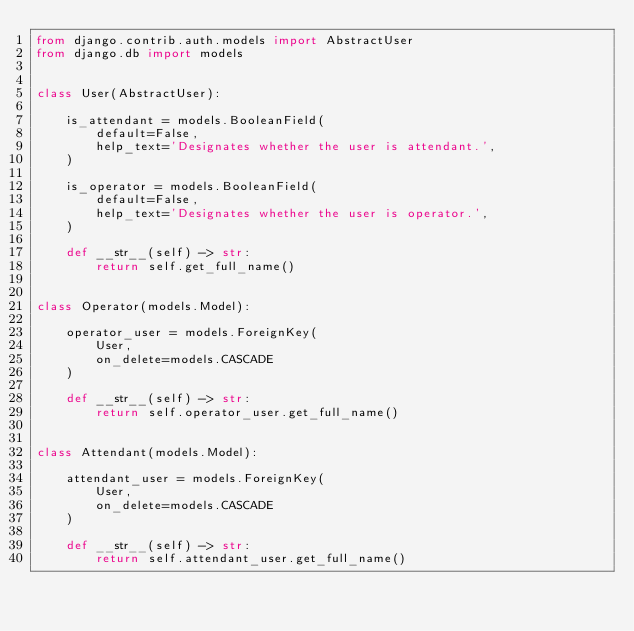<code> <loc_0><loc_0><loc_500><loc_500><_Python_>from django.contrib.auth.models import AbstractUser
from django.db import models


class User(AbstractUser):

    is_attendant = models.BooleanField(
        default=False,
        help_text='Designates whether the user is attendant.',
    )

    is_operator = models.BooleanField(
        default=False,
        help_text='Designates whether the user is operator.',
    )

    def __str__(self) -> str:
        return self.get_full_name()


class Operator(models.Model):

    operator_user = models.ForeignKey(
        User, 
        on_delete=models.CASCADE
    )

    def __str__(self) -> str:
        return self.operator_user.get_full_name()


class Attendant(models.Model):

    attendant_user = models.ForeignKey(
        User, 
        on_delete=models.CASCADE
    )

    def __str__(self) -> str:
        return self.attendant_user.get_full_name()
</code> 